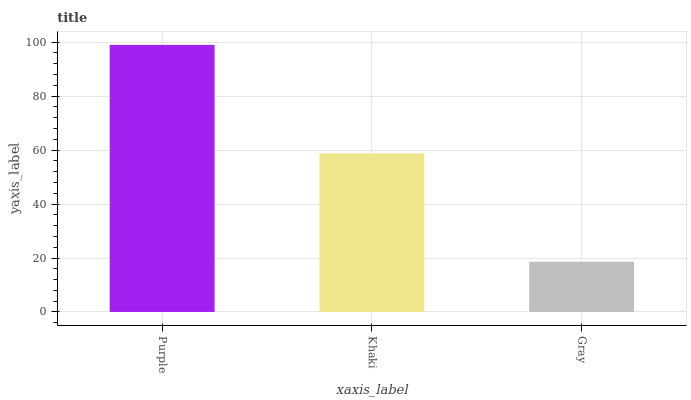Is Gray the minimum?
Answer yes or no. Yes. Is Purple the maximum?
Answer yes or no. Yes. Is Khaki the minimum?
Answer yes or no. No. Is Khaki the maximum?
Answer yes or no. No. Is Purple greater than Khaki?
Answer yes or no. Yes. Is Khaki less than Purple?
Answer yes or no. Yes. Is Khaki greater than Purple?
Answer yes or no. No. Is Purple less than Khaki?
Answer yes or no. No. Is Khaki the high median?
Answer yes or no. Yes. Is Khaki the low median?
Answer yes or no. Yes. Is Gray the high median?
Answer yes or no. No. Is Gray the low median?
Answer yes or no. No. 